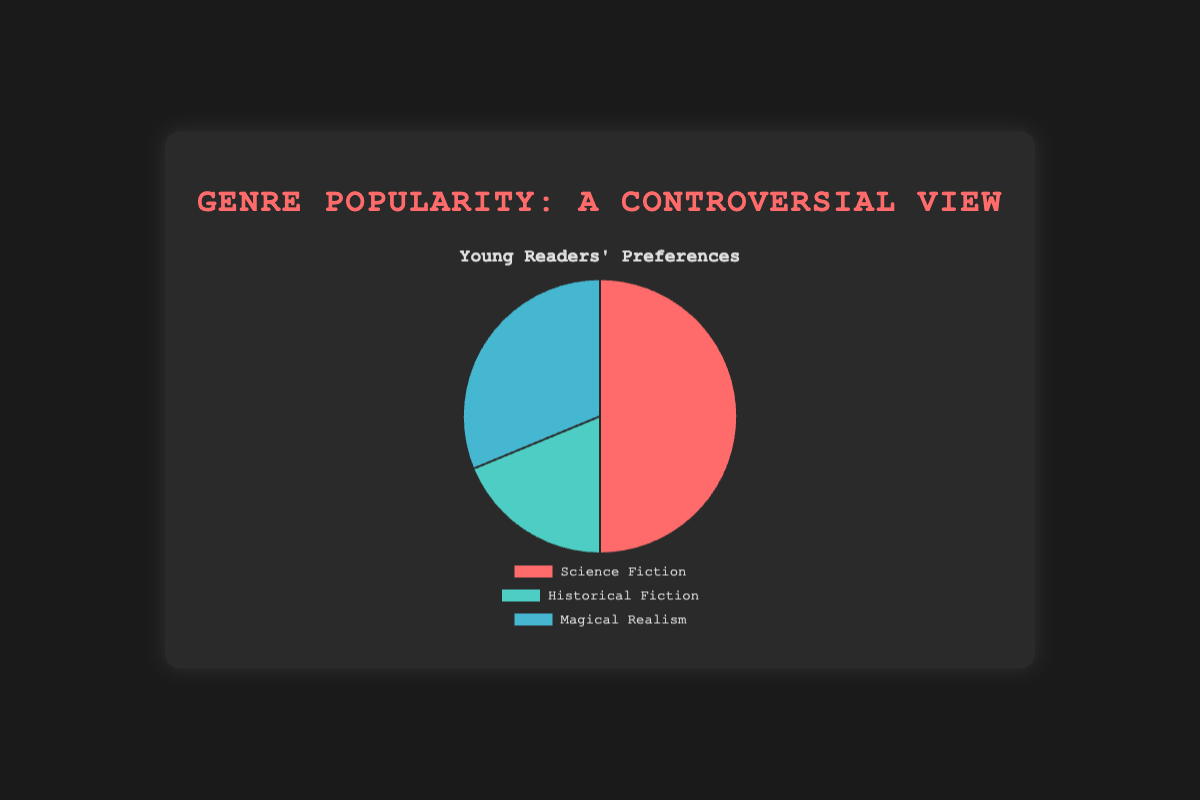What's the most popular genre among young readers? The pie chart title indicates it represents young readers' preferences. Looking at the largest slice, it is the red slice labeled "Science Fiction".
Answer: Science Fiction How many times more popular is Science Fiction than Historical Fiction among young readers? The percentage for Science Fiction is 40%, and for Historical Fiction is 15%. Dividing 40 by 15 gives approximately 2.67. So, Science Fiction is about 2.67 times more popular than Historical Fiction among young readers.
Answer: 2.67 What is the combined percentage of Historical Fiction and Magical Realism among young readers? The chart shows 15% for Historical Fiction and 25% for Magical Realism. Adding these together gives 15 + 25 = 40%.
Answer: 40% Is Science Fiction more than twice as popular as Psychological Thriller among young readers? The chart shows Science Fiction at 40% and Psychological Thriller is not one of the genres in the pie chart. Considering only the genres in the chart, Science Fiction is not compared with Psychological Thriller.
Answer: No Which genre occupies the least space in the pie chart? The smallest slice in the pie chart belongs to the green slice, which is labeled "Historical Fiction" at 15%.
Answer: Historical Fiction 